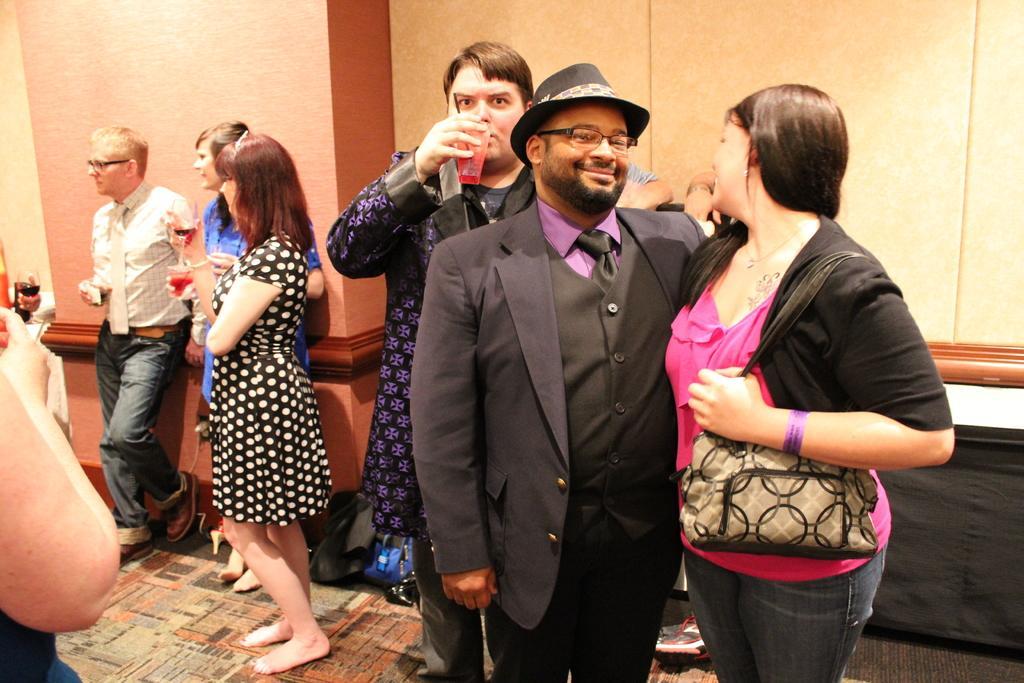Describe this image in one or two sentences. In the center of the image we can see some persons are standing. Some of them holding a glass. On the right side of the image a lady is wearing a bag. In the background of the image a wall is there. At the bottom of the image we can see some bags, floor are present. 